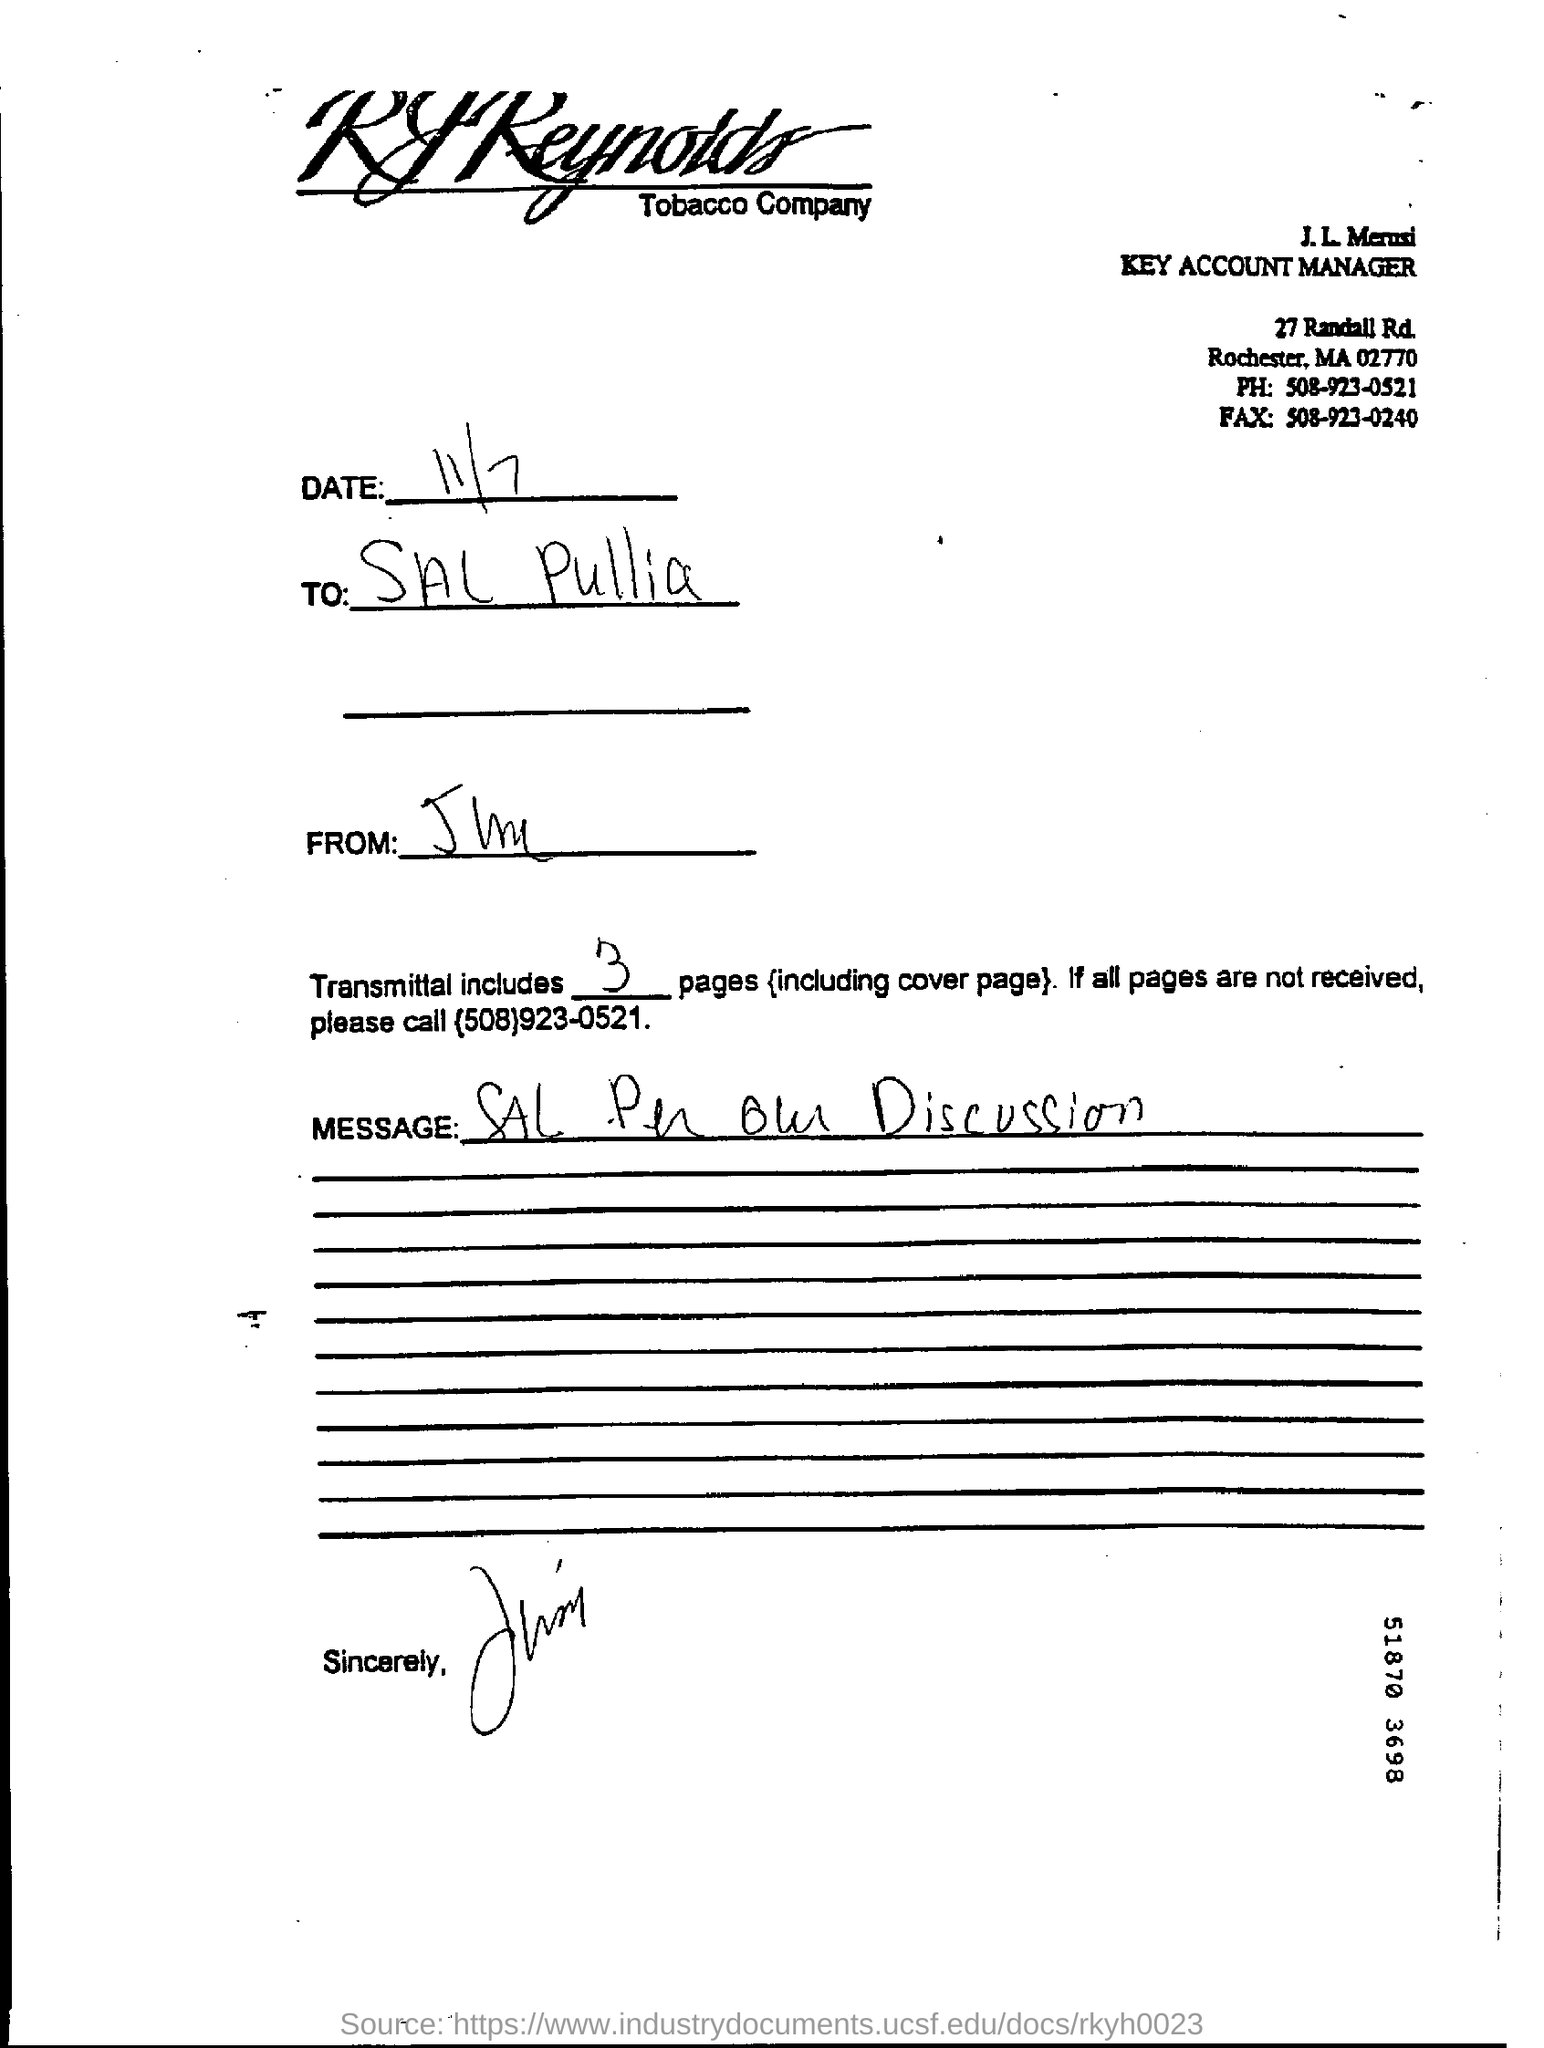Identify some key points in this picture. The phone number of the J.L. Merusi is 508-923-0521. The J.L. Merusi's fax number is 508-923-0240. The date in the document is November 7th. 